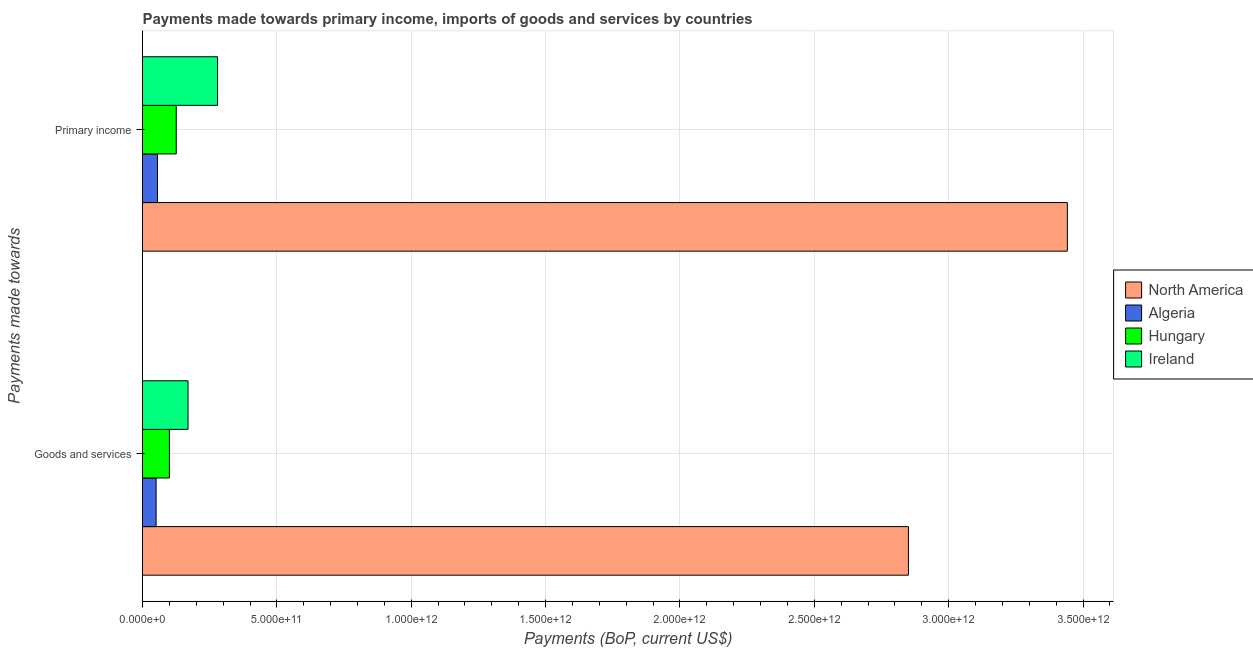How many groups of bars are there?
Your answer should be very brief. 2. Are the number of bars per tick equal to the number of legend labels?
Offer a terse response. Yes. How many bars are there on the 2nd tick from the top?
Your response must be concise. 4. How many bars are there on the 2nd tick from the bottom?
Give a very brief answer. 4. What is the label of the 1st group of bars from the top?
Provide a short and direct response. Primary income. What is the payments made towards primary income in Algeria?
Offer a terse response. 5.56e+1. Across all countries, what is the maximum payments made towards goods and services?
Offer a terse response. 2.85e+12. Across all countries, what is the minimum payments made towards goods and services?
Make the answer very short. 5.06e+1. In which country was the payments made towards goods and services maximum?
Ensure brevity in your answer.  North America. In which country was the payments made towards goods and services minimum?
Offer a terse response. Algeria. What is the total payments made towards goods and services in the graph?
Ensure brevity in your answer.  3.17e+12. What is the difference between the payments made towards primary income in Hungary and that in Ireland?
Your response must be concise. -1.54e+11. What is the difference between the payments made towards primary income in Algeria and the payments made towards goods and services in North America?
Make the answer very short. -2.79e+12. What is the average payments made towards primary income per country?
Your answer should be very brief. 9.76e+11. What is the difference between the payments made towards goods and services and payments made towards primary income in Algeria?
Provide a short and direct response. -4.97e+09. In how many countries, is the payments made towards goods and services greater than 2100000000000 US$?
Your answer should be very brief. 1. What is the ratio of the payments made towards goods and services in North America to that in Algeria?
Make the answer very short. 56.27. Is the payments made towards goods and services in Ireland less than that in Hungary?
Your answer should be compact. No. In how many countries, is the payments made towards primary income greater than the average payments made towards primary income taken over all countries?
Make the answer very short. 1. What does the 3rd bar from the top in Goods and services represents?
Give a very brief answer. Algeria. What does the 3rd bar from the bottom in Goods and services represents?
Give a very brief answer. Hungary. What is the difference between two consecutive major ticks on the X-axis?
Offer a very short reply. 5.00e+11. Are the values on the major ticks of X-axis written in scientific E-notation?
Offer a very short reply. Yes. Does the graph contain any zero values?
Your answer should be very brief. No. How many legend labels are there?
Provide a succinct answer. 4. How are the legend labels stacked?
Provide a short and direct response. Vertical. What is the title of the graph?
Your answer should be very brief. Payments made towards primary income, imports of goods and services by countries. Does "Dominica" appear as one of the legend labels in the graph?
Ensure brevity in your answer.  No. What is the label or title of the X-axis?
Your answer should be very brief. Payments (BoP, current US$). What is the label or title of the Y-axis?
Your response must be concise. Payments made towards. What is the Payments (BoP, current US$) of North America in Goods and services?
Provide a short and direct response. 2.85e+12. What is the Payments (BoP, current US$) of Algeria in Goods and services?
Give a very brief answer. 5.06e+1. What is the Payments (BoP, current US$) of Hungary in Goods and services?
Your response must be concise. 1.00e+11. What is the Payments (BoP, current US$) in Ireland in Goods and services?
Give a very brief answer. 1.69e+11. What is the Payments (BoP, current US$) in North America in Primary income?
Offer a terse response. 3.44e+12. What is the Payments (BoP, current US$) in Algeria in Primary income?
Provide a short and direct response. 5.56e+1. What is the Payments (BoP, current US$) of Hungary in Primary income?
Ensure brevity in your answer.  1.26e+11. What is the Payments (BoP, current US$) in Ireland in Primary income?
Provide a short and direct response. 2.79e+11. Across all Payments made towards, what is the maximum Payments (BoP, current US$) in North America?
Give a very brief answer. 3.44e+12. Across all Payments made towards, what is the maximum Payments (BoP, current US$) in Algeria?
Ensure brevity in your answer.  5.56e+1. Across all Payments made towards, what is the maximum Payments (BoP, current US$) of Hungary?
Offer a terse response. 1.26e+11. Across all Payments made towards, what is the maximum Payments (BoP, current US$) of Ireland?
Your answer should be compact. 2.79e+11. Across all Payments made towards, what is the minimum Payments (BoP, current US$) in North America?
Make the answer very short. 2.85e+12. Across all Payments made towards, what is the minimum Payments (BoP, current US$) in Algeria?
Keep it short and to the point. 5.06e+1. Across all Payments made towards, what is the minimum Payments (BoP, current US$) of Hungary?
Make the answer very short. 1.00e+11. Across all Payments made towards, what is the minimum Payments (BoP, current US$) of Ireland?
Make the answer very short. 1.69e+11. What is the total Payments (BoP, current US$) in North America in the graph?
Keep it short and to the point. 6.29e+12. What is the total Payments (BoP, current US$) in Algeria in the graph?
Offer a terse response. 1.06e+11. What is the total Payments (BoP, current US$) of Hungary in the graph?
Your answer should be very brief. 2.26e+11. What is the total Payments (BoP, current US$) of Ireland in the graph?
Your response must be concise. 4.49e+11. What is the difference between the Payments (BoP, current US$) in North America in Goods and services and that in Primary income?
Your answer should be very brief. -5.91e+11. What is the difference between the Payments (BoP, current US$) in Algeria in Goods and services and that in Primary income?
Keep it short and to the point. -4.97e+09. What is the difference between the Payments (BoP, current US$) in Hungary in Goods and services and that in Primary income?
Ensure brevity in your answer.  -2.54e+1. What is the difference between the Payments (BoP, current US$) of Ireland in Goods and services and that in Primary income?
Provide a short and direct response. -1.10e+11. What is the difference between the Payments (BoP, current US$) of North America in Goods and services and the Payments (BoP, current US$) of Algeria in Primary income?
Provide a succinct answer. 2.79e+12. What is the difference between the Payments (BoP, current US$) of North America in Goods and services and the Payments (BoP, current US$) of Hungary in Primary income?
Your answer should be compact. 2.72e+12. What is the difference between the Payments (BoP, current US$) in North America in Goods and services and the Payments (BoP, current US$) in Ireland in Primary income?
Your answer should be very brief. 2.57e+12. What is the difference between the Payments (BoP, current US$) of Algeria in Goods and services and the Payments (BoP, current US$) of Hungary in Primary income?
Ensure brevity in your answer.  -7.49e+1. What is the difference between the Payments (BoP, current US$) in Algeria in Goods and services and the Payments (BoP, current US$) in Ireland in Primary income?
Provide a short and direct response. -2.29e+11. What is the difference between the Payments (BoP, current US$) in Hungary in Goods and services and the Payments (BoP, current US$) in Ireland in Primary income?
Your answer should be compact. -1.79e+11. What is the average Payments (BoP, current US$) in North America per Payments made towards?
Your answer should be very brief. 3.15e+12. What is the average Payments (BoP, current US$) in Algeria per Payments made towards?
Provide a succinct answer. 5.31e+1. What is the average Payments (BoP, current US$) of Hungary per Payments made towards?
Your answer should be very brief. 1.13e+11. What is the average Payments (BoP, current US$) of Ireland per Payments made towards?
Offer a very short reply. 2.24e+11. What is the difference between the Payments (BoP, current US$) in North America and Payments (BoP, current US$) in Algeria in Goods and services?
Offer a terse response. 2.80e+12. What is the difference between the Payments (BoP, current US$) in North America and Payments (BoP, current US$) in Hungary in Goods and services?
Make the answer very short. 2.75e+12. What is the difference between the Payments (BoP, current US$) of North America and Payments (BoP, current US$) of Ireland in Goods and services?
Offer a terse response. 2.68e+12. What is the difference between the Payments (BoP, current US$) of Algeria and Payments (BoP, current US$) of Hungary in Goods and services?
Offer a very short reply. -4.95e+1. What is the difference between the Payments (BoP, current US$) in Algeria and Payments (BoP, current US$) in Ireland in Goods and services?
Give a very brief answer. -1.19e+11. What is the difference between the Payments (BoP, current US$) in Hungary and Payments (BoP, current US$) in Ireland in Goods and services?
Provide a succinct answer. -6.93e+1. What is the difference between the Payments (BoP, current US$) of North America and Payments (BoP, current US$) of Algeria in Primary income?
Offer a very short reply. 3.39e+12. What is the difference between the Payments (BoP, current US$) of North America and Payments (BoP, current US$) of Hungary in Primary income?
Your answer should be very brief. 3.32e+12. What is the difference between the Payments (BoP, current US$) of North America and Payments (BoP, current US$) of Ireland in Primary income?
Offer a terse response. 3.16e+12. What is the difference between the Payments (BoP, current US$) of Algeria and Payments (BoP, current US$) of Hungary in Primary income?
Offer a very short reply. -6.99e+1. What is the difference between the Payments (BoP, current US$) of Algeria and Payments (BoP, current US$) of Ireland in Primary income?
Offer a very short reply. -2.24e+11. What is the difference between the Payments (BoP, current US$) in Hungary and Payments (BoP, current US$) in Ireland in Primary income?
Give a very brief answer. -1.54e+11. What is the ratio of the Payments (BoP, current US$) of North America in Goods and services to that in Primary income?
Offer a very short reply. 0.83. What is the ratio of the Payments (BoP, current US$) in Algeria in Goods and services to that in Primary income?
Offer a terse response. 0.91. What is the ratio of the Payments (BoP, current US$) of Hungary in Goods and services to that in Primary income?
Offer a terse response. 0.8. What is the ratio of the Payments (BoP, current US$) in Ireland in Goods and services to that in Primary income?
Your response must be concise. 0.61. What is the difference between the highest and the second highest Payments (BoP, current US$) in North America?
Provide a succinct answer. 5.91e+11. What is the difference between the highest and the second highest Payments (BoP, current US$) in Algeria?
Give a very brief answer. 4.97e+09. What is the difference between the highest and the second highest Payments (BoP, current US$) of Hungary?
Provide a succinct answer. 2.54e+1. What is the difference between the highest and the second highest Payments (BoP, current US$) in Ireland?
Give a very brief answer. 1.10e+11. What is the difference between the highest and the lowest Payments (BoP, current US$) of North America?
Keep it short and to the point. 5.91e+11. What is the difference between the highest and the lowest Payments (BoP, current US$) in Algeria?
Offer a terse response. 4.97e+09. What is the difference between the highest and the lowest Payments (BoP, current US$) of Hungary?
Offer a terse response. 2.54e+1. What is the difference between the highest and the lowest Payments (BoP, current US$) of Ireland?
Make the answer very short. 1.10e+11. 